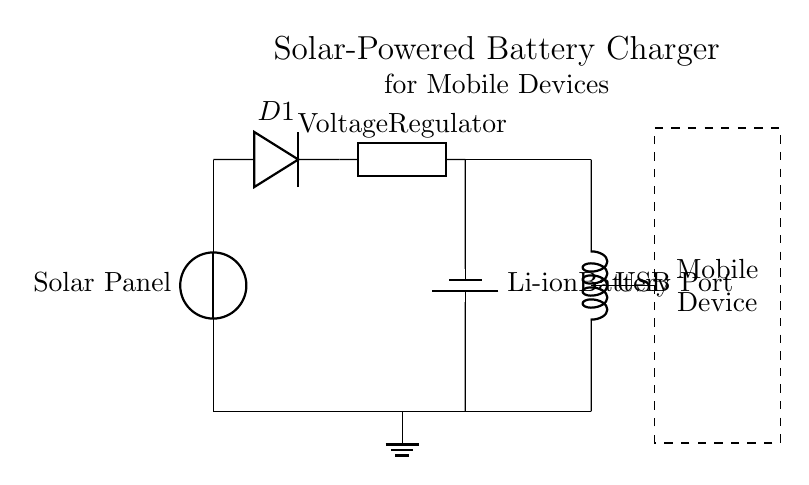What component converts solar energy into electrical energy? The circuit diagram shows a solar panel, which is the component that converts solar energy into electrical energy. This is indicated at the top of the diagram labeled as "Solar Panel."
Answer: Solar Panel What is the purpose of the diode in this circuit? The diode (labeled D1) allows current to flow in one direction only, preventing backflow of current from the battery to the solar panel when there's insufficient light. This ensures the integrity and charging efficiency of the circuit.
Answer: Prevents backflow What type of battery is used in this circuit? The circuit diagram specifies a Li-ion battery, labeled as "Li-ion Battery" towards the bottom right of the diagram. This information directly answers the battery type question.
Answer: Li-ion Battery How does the voltage regulator function in this circuit? The voltage regulator (depicted in the center of the circuit) ensures that the output voltage remains stable and suitable for charging the mobile device regardless of fluctuations in the solar panel's output voltage. This stability is essential for optimal battery charging and device safety.
Answer: Stabilizes voltage What connects the battery to the USB port? A direct connection from the battery to the USB port is shown, where current flows from the battery to the USB port to charge mobile devices. This indicates that the USB port draws power directly from the battery, ensuring the mobile device can be charged.
Answer: USB Port What happens when the mobile device is connected? When the mobile device is connected, the circuit allows current flow through the USB port to the device, enabling it to be charged. Since the USB port is designed to interface with mobile devices, the device will draw power from the battery controlled by the voltage regulator.
Answer: Charges mobile device How is the overall circuit grounded? The circuit has a ground connection depicted at the bottom, connecting all components to a common ground, indicated by the ground symbol. This is critical for the safety and stability of the entire circuit.
Answer: Ground connection 